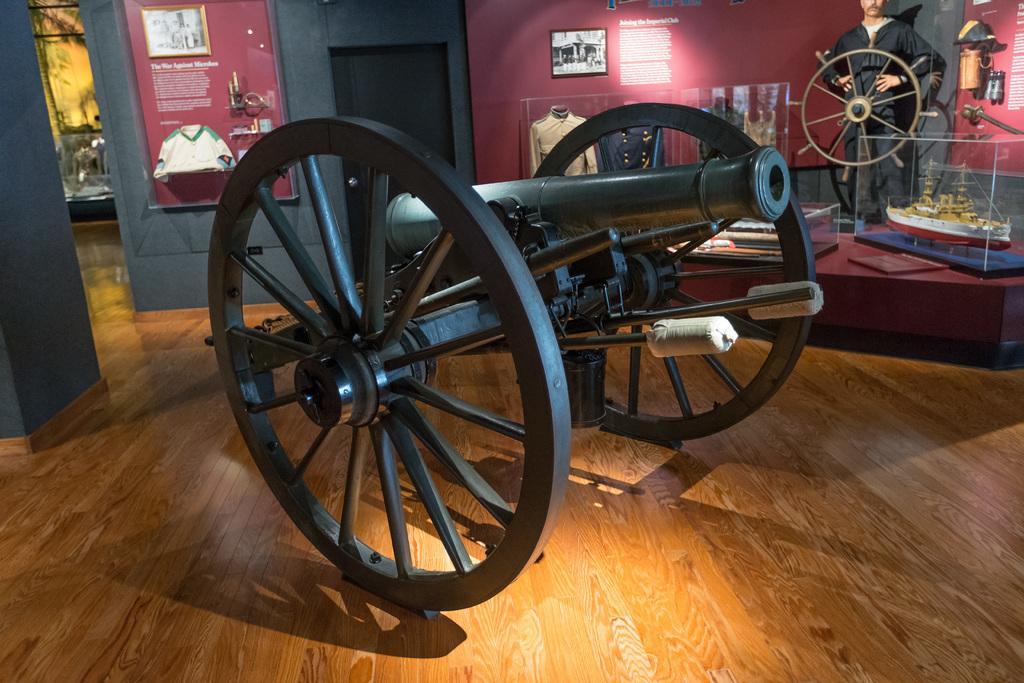In one or two sentences, can you explain what this image depicts? In this picture we can see a cannon in the front, in the background there is a wall and a door, we can see photo frame on the wall, on the left side there is a board, we can see some text on the board, on the right side we can see a statue of a person, steering and clothes, we can also see a replica of a ship. At the bottom there is floor. 